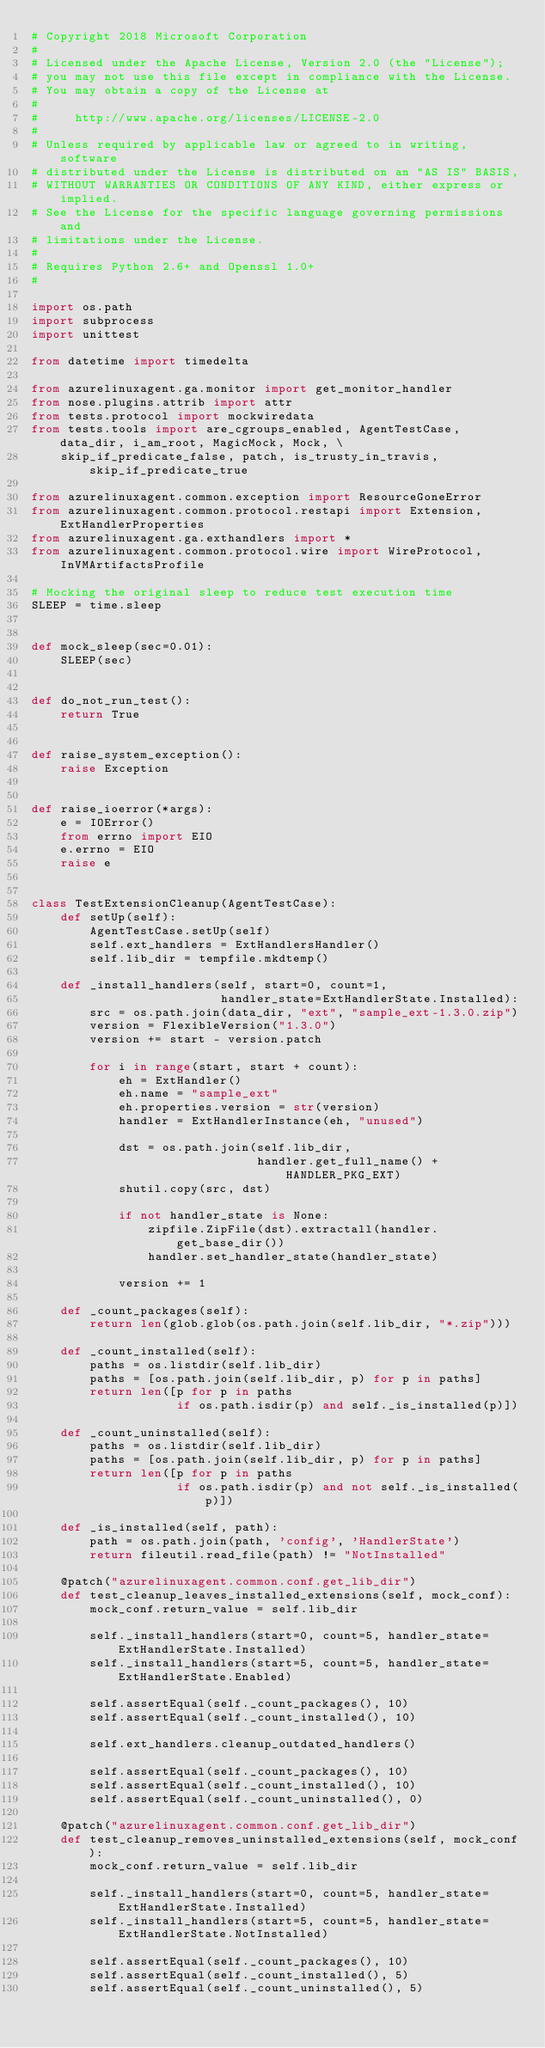<code> <loc_0><loc_0><loc_500><loc_500><_Python_># Copyright 2018 Microsoft Corporation
#
# Licensed under the Apache License, Version 2.0 (the "License");
# you may not use this file except in compliance with the License.
# You may obtain a copy of the License at
#
#     http://www.apache.org/licenses/LICENSE-2.0
#
# Unless required by applicable law or agreed to in writing, software
# distributed under the License is distributed on an "AS IS" BASIS,
# WITHOUT WARRANTIES OR CONDITIONS OF ANY KIND, either express or implied.
# See the License for the specific language governing permissions and
# limitations under the License.
#
# Requires Python 2.6+ and Openssl 1.0+
#

import os.path
import subprocess
import unittest

from datetime import timedelta

from azurelinuxagent.ga.monitor import get_monitor_handler
from nose.plugins.attrib import attr
from tests.protocol import mockwiredata
from tests.tools import are_cgroups_enabled, AgentTestCase, data_dir, i_am_root, MagicMock, Mock, \
    skip_if_predicate_false, patch, is_trusty_in_travis, skip_if_predicate_true

from azurelinuxagent.common.exception import ResourceGoneError
from azurelinuxagent.common.protocol.restapi import Extension, ExtHandlerProperties
from azurelinuxagent.ga.exthandlers import *
from azurelinuxagent.common.protocol.wire import WireProtocol, InVMArtifactsProfile

# Mocking the original sleep to reduce test execution time
SLEEP = time.sleep


def mock_sleep(sec=0.01):
    SLEEP(sec)


def do_not_run_test():
    return True


def raise_system_exception():
    raise Exception


def raise_ioerror(*args):
    e = IOError()
    from errno import EIO
    e.errno = EIO
    raise e


class TestExtensionCleanup(AgentTestCase):
    def setUp(self):
        AgentTestCase.setUp(self)
        self.ext_handlers = ExtHandlersHandler()
        self.lib_dir = tempfile.mkdtemp()

    def _install_handlers(self, start=0, count=1,
                          handler_state=ExtHandlerState.Installed):
        src = os.path.join(data_dir, "ext", "sample_ext-1.3.0.zip")
        version = FlexibleVersion("1.3.0")
        version += start - version.patch

        for i in range(start, start + count):
            eh = ExtHandler()
            eh.name = "sample_ext"
            eh.properties.version = str(version)
            handler = ExtHandlerInstance(eh, "unused")

            dst = os.path.join(self.lib_dir,
                               handler.get_full_name() + HANDLER_PKG_EXT)
            shutil.copy(src, dst)

            if not handler_state is None:
                zipfile.ZipFile(dst).extractall(handler.get_base_dir())
                handler.set_handler_state(handler_state)

            version += 1

    def _count_packages(self):
        return len(glob.glob(os.path.join(self.lib_dir, "*.zip")))

    def _count_installed(self):
        paths = os.listdir(self.lib_dir)
        paths = [os.path.join(self.lib_dir, p) for p in paths]
        return len([p for p in paths
                    if os.path.isdir(p) and self._is_installed(p)])

    def _count_uninstalled(self):
        paths = os.listdir(self.lib_dir)
        paths = [os.path.join(self.lib_dir, p) for p in paths]
        return len([p for p in paths
                    if os.path.isdir(p) and not self._is_installed(p)])

    def _is_installed(self, path):
        path = os.path.join(path, 'config', 'HandlerState')
        return fileutil.read_file(path) != "NotInstalled"

    @patch("azurelinuxagent.common.conf.get_lib_dir")
    def test_cleanup_leaves_installed_extensions(self, mock_conf):
        mock_conf.return_value = self.lib_dir

        self._install_handlers(start=0, count=5, handler_state=ExtHandlerState.Installed)
        self._install_handlers(start=5, count=5, handler_state=ExtHandlerState.Enabled)

        self.assertEqual(self._count_packages(), 10)
        self.assertEqual(self._count_installed(), 10)

        self.ext_handlers.cleanup_outdated_handlers()

        self.assertEqual(self._count_packages(), 10)
        self.assertEqual(self._count_installed(), 10)
        self.assertEqual(self._count_uninstalled(), 0)

    @patch("azurelinuxagent.common.conf.get_lib_dir")
    def test_cleanup_removes_uninstalled_extensions(self, mock_conf):
        mock_conf.return_value = self.lib_dir

        self._install_handlers(start=0, count=5, handler_state=ExtHandlerState.Installed)
        self._install_handlers(start=5, count=5, handler_state=ExtHandlerState.NotInstalled)

        self.assertEqual(self._count_packages(), 10)
        self.assertEqual(self._count_installed(), 5)
        self.assertEqual(self._count_uninstalled(), 5)
</code> 